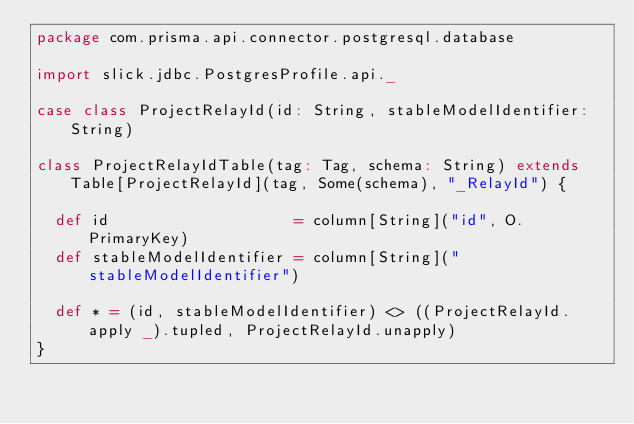Convert code to text. <code><loc_0><loc_0><loc_500><loc_500><_Scala_>package com.prisma.api.connector.postgresql.database

import slick.jdbc.PostgresProfile.api._

case class ProjectRelayId(id: String, stableModelIdentifier: String)

class ProjectRelayIdTable(tag: Tag, schema: String) extends Table[ProjectRelayId](tag, Some(schema), "_RelayId") {

  def id                    = column[String]("id", O.PrimaryKey)
  def stableModelIdentifier = column[String]("stableModelIdentifier")

  def * = (id, stableModelIdentifier) <> ((ProjectRelayId.apply _).tupled, ProjectRelayId.unapply)
}
</code> 